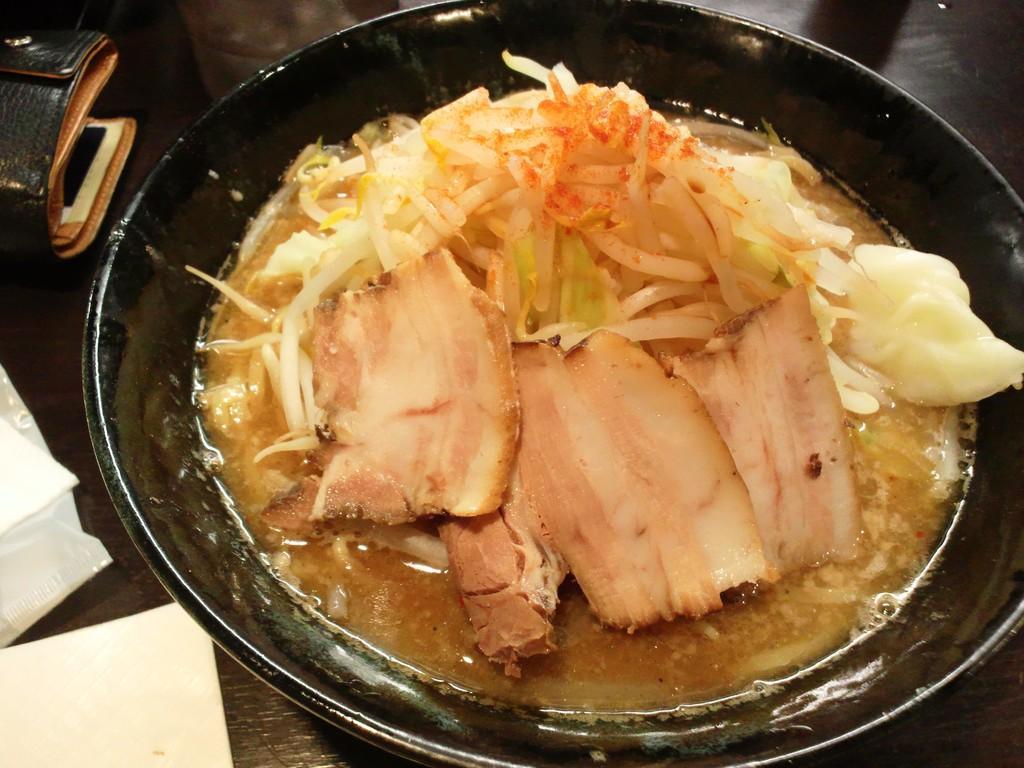Please provide a concise description of this image. In this image there is a food item placed in a dish, which is on the black color surface and there are tissues and a purse. 